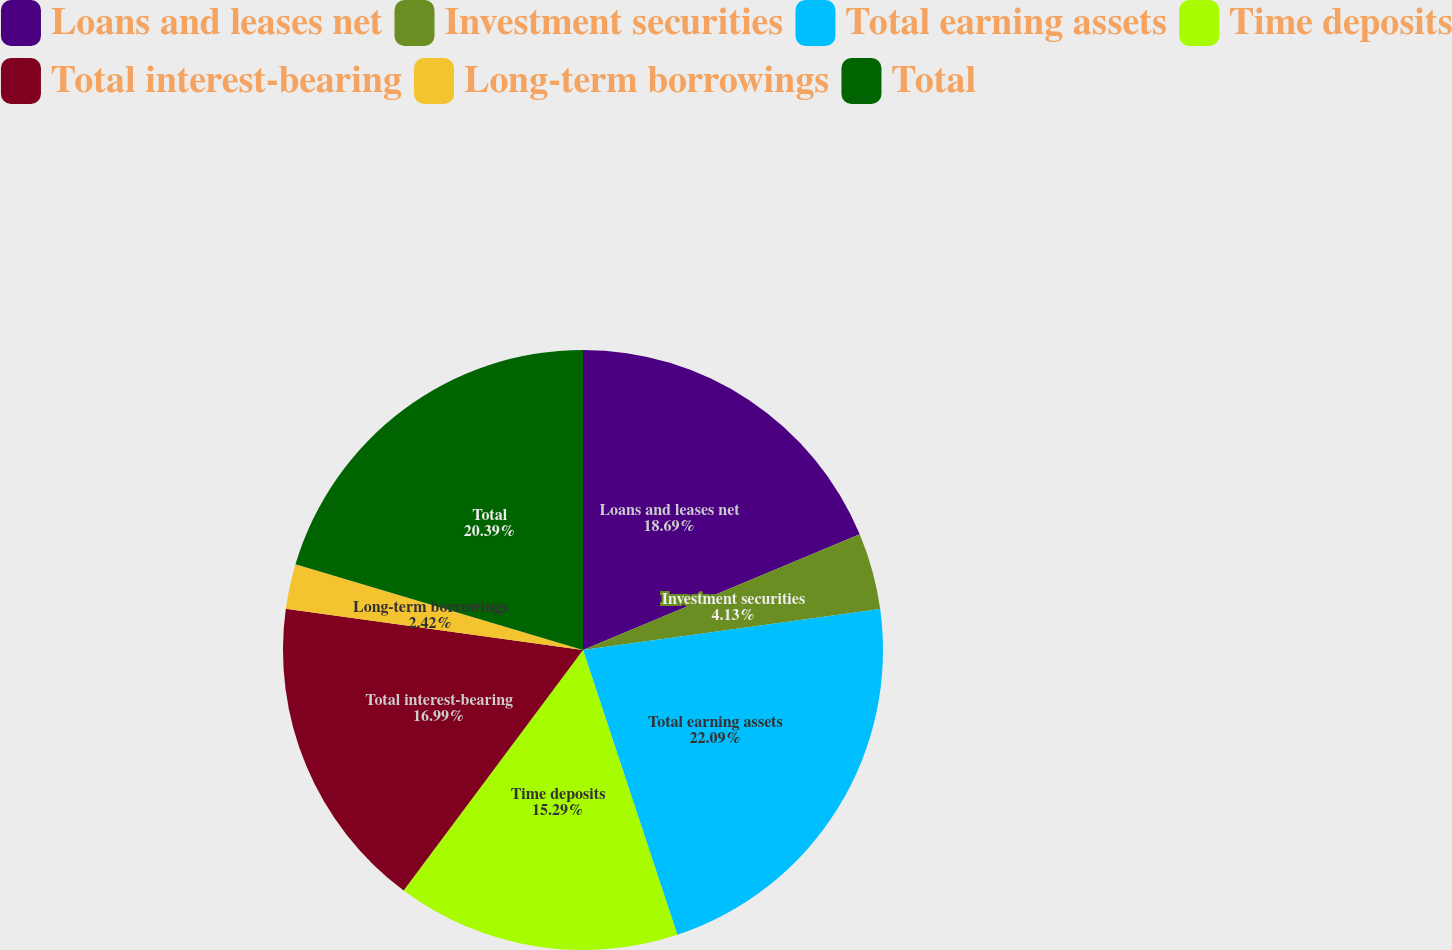Convert chart. <chart><loc_0><loc_0><loc_500><loc_500><pie_chart><fcel>Loans and leases net<fcel>Investment securities<fcel>Total earning assets<fcel>Time deposits<fcel>Total interest-bearing<fcel>Long-term borrowings<fcel>Total<nl><fcel>18.69%<fcel>4.13%<fcel>22.09%<fcel>15.29%<fcel>16.99%<fcel>2.42%<fcel>20.39%<nl></chart> 